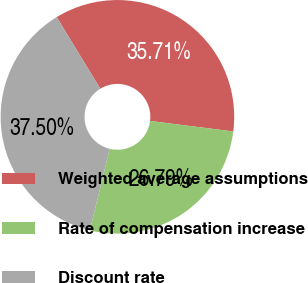<chart> <loc_0><loc_0><loc_500><loc_500><pie_chart><fcel>Weighted average assumptions<fcel>Rate of compensation increase<fcel>Discount rate<nl><fcel>35.71%<fcel>26.79%<fcel>37.5%<nl></chart> 